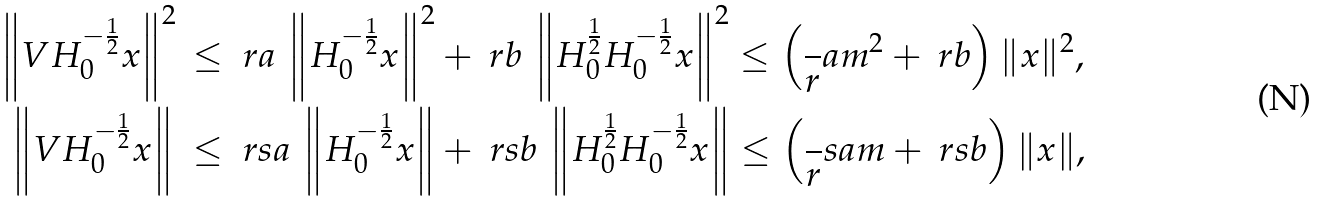Convert formula to latex. <formula><loc_0><loc_0><loc_500><loc_500>\left \| V H _ { 0 } ^ { - \frac { 1 } { 2 } } x \right \| ^ { 2 } \, & \leq \ r a \, \left \| H _ { 0 } ^ { - \frac { 1 } { 2 } } x \right \| ^ { 2 } + \ r b \, \left \| H _ { 0 } ^ { \frac { 1 } { 2 } } H _ { 0 } ^ { - \frac { 1 } { 2 } } x \right \| ^ { 2 } \leq \left ( \frac { \ } { r } a { m ^ { 2 } } + \ r b \right ) \| x \| ^ { 2 } , \\ \left \| V H _ { 0 } ^ { - \frac { 1 } { 2 } } x \right \| \ & \leq \ r s a \, \left \| H _ { 0 } ^ { - \frac { 1 } { 2 } } x \right \| + \ r s b \, \left \| H _ { 0 } ^ { \frac { 1 } { 2 } } H _ { 0 } ^ { - \frac { 1 } { 2 } } x \right \| \leq \left ( \frac { \ } { r } s a m + \ r s b \right ) \| x \| ,</formula> 